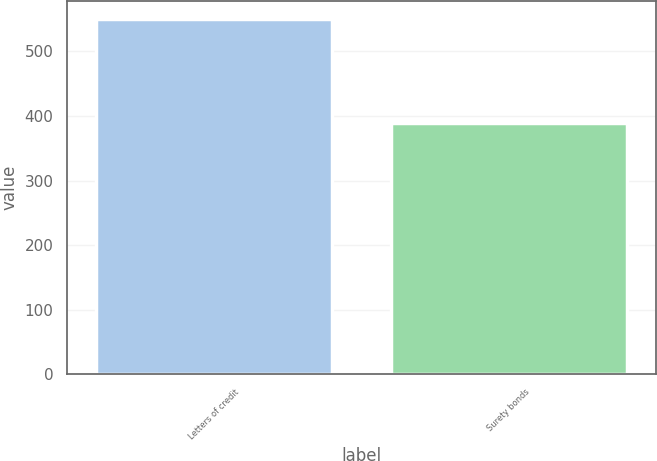Convert chart to OTSL. <chart><loc_0><loc_0><loc_500><loc_500><bar_chart><fcel>Letters of credit<fcel>Surety bonds<nl><fcel>550.3<fcel>388.7<nl></chart> 